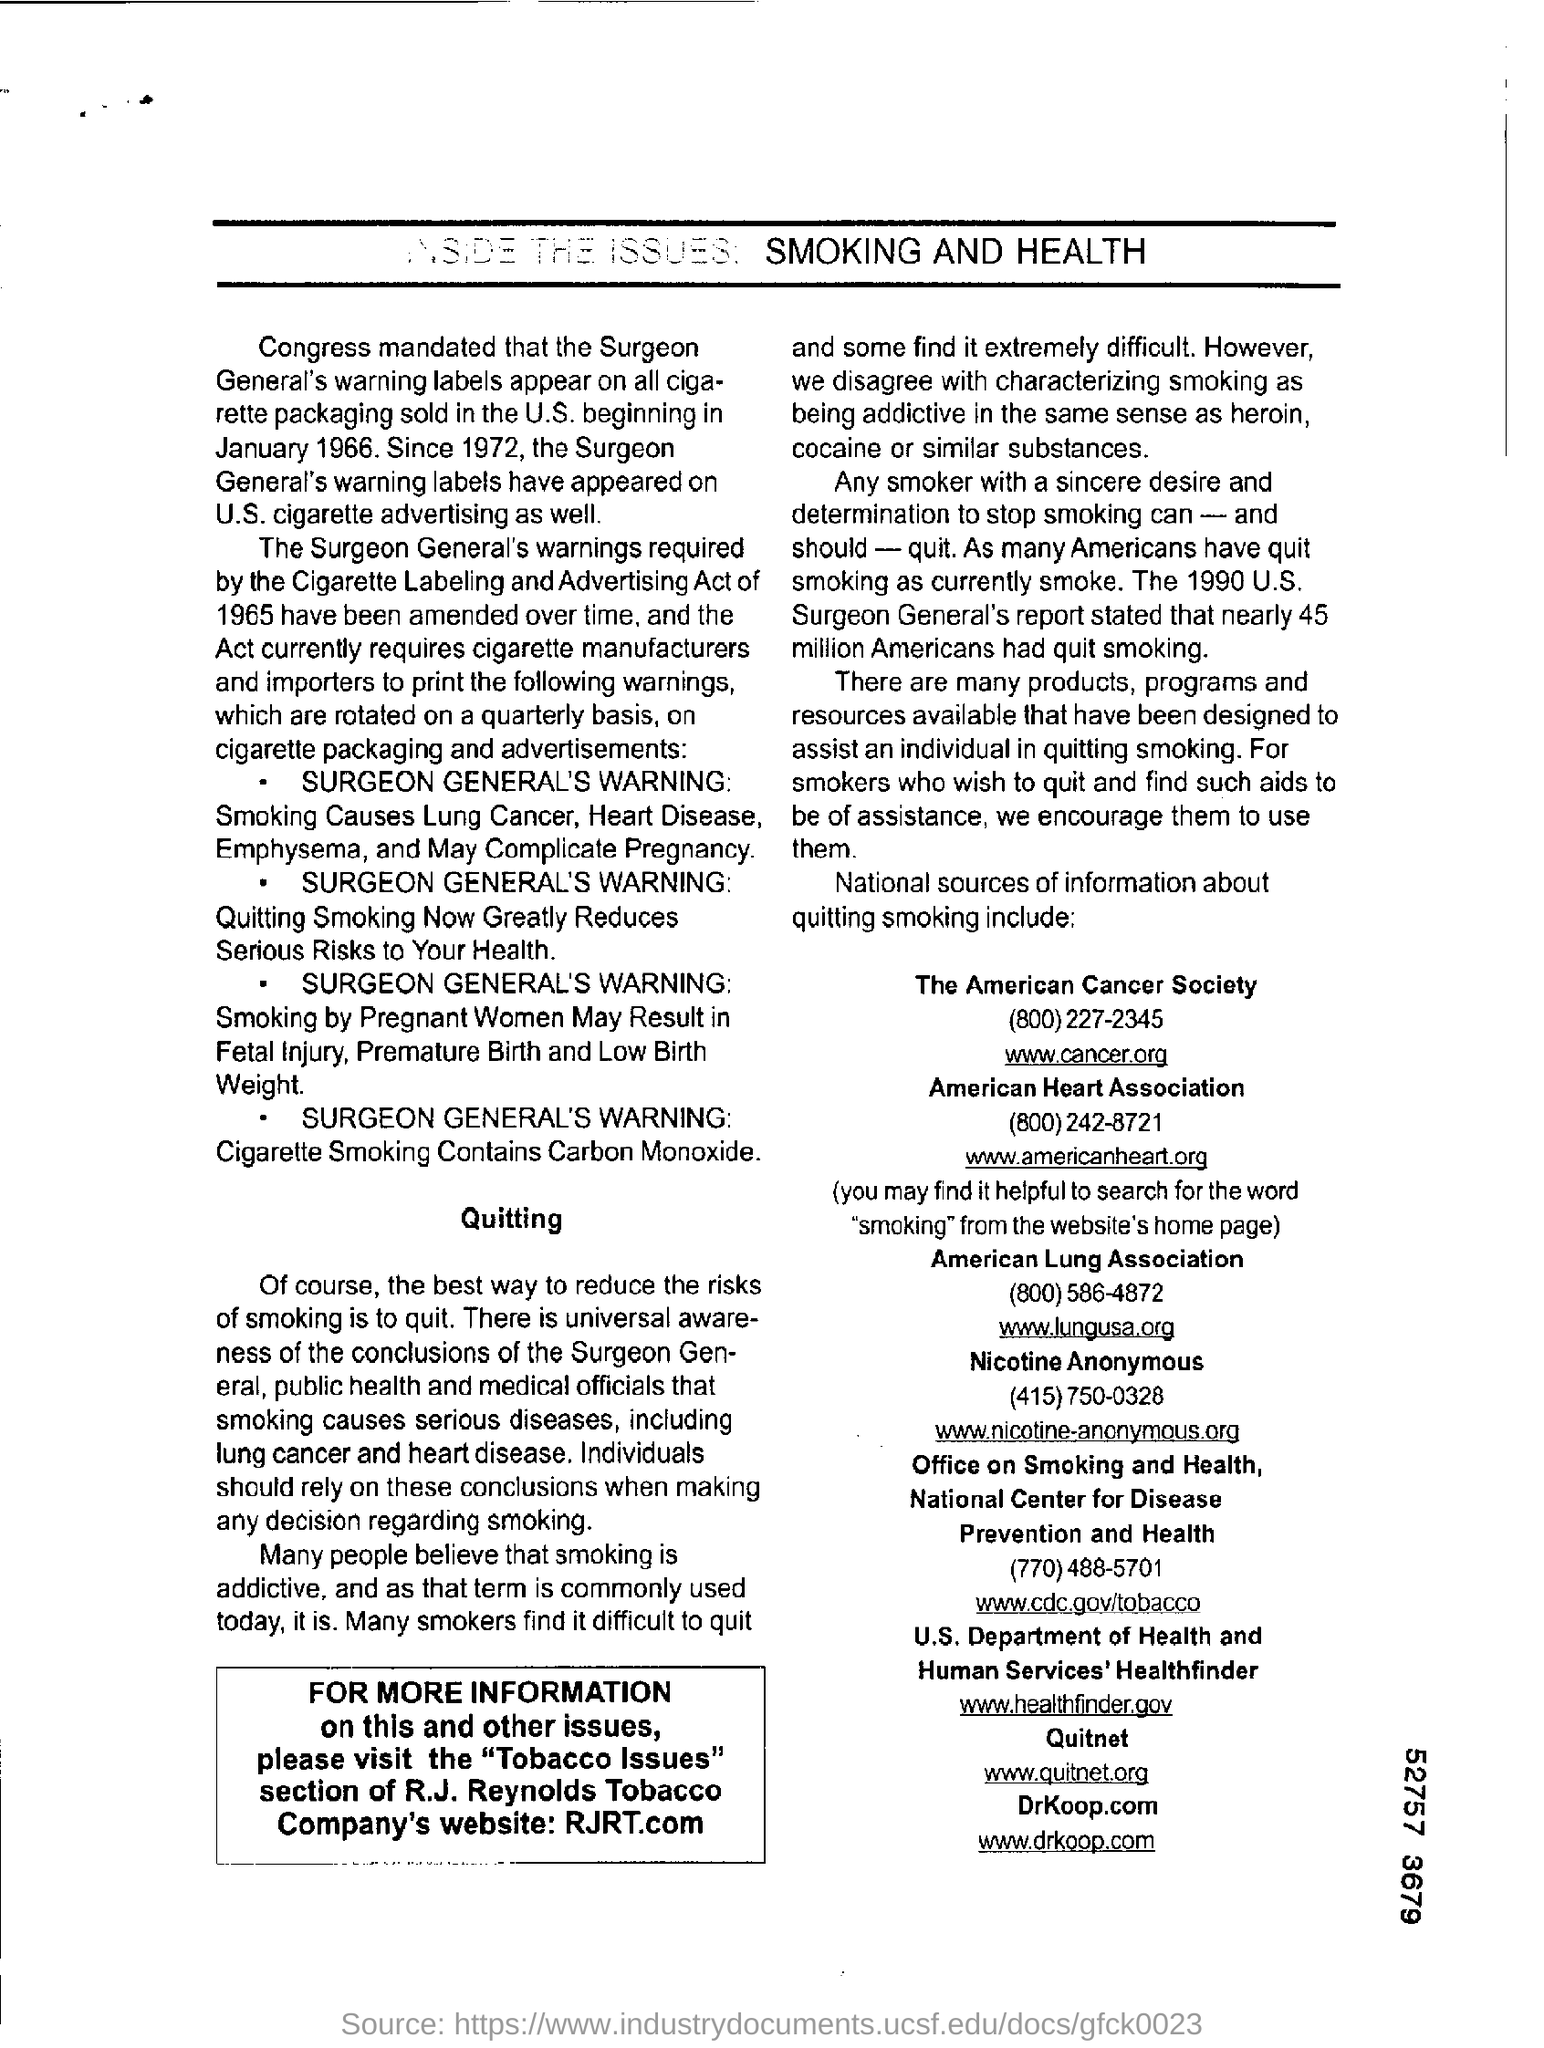Draw attention to some important aspects in this diagram. The American Cancer Society can be contacted through their email address [info@cancer.org](mailto:info@cancer.org). The American Heart Association's email address is [www.americanheart.org](http://www.americanheart.org). The contact number of the American Cancer Society is (800)227-2345. 